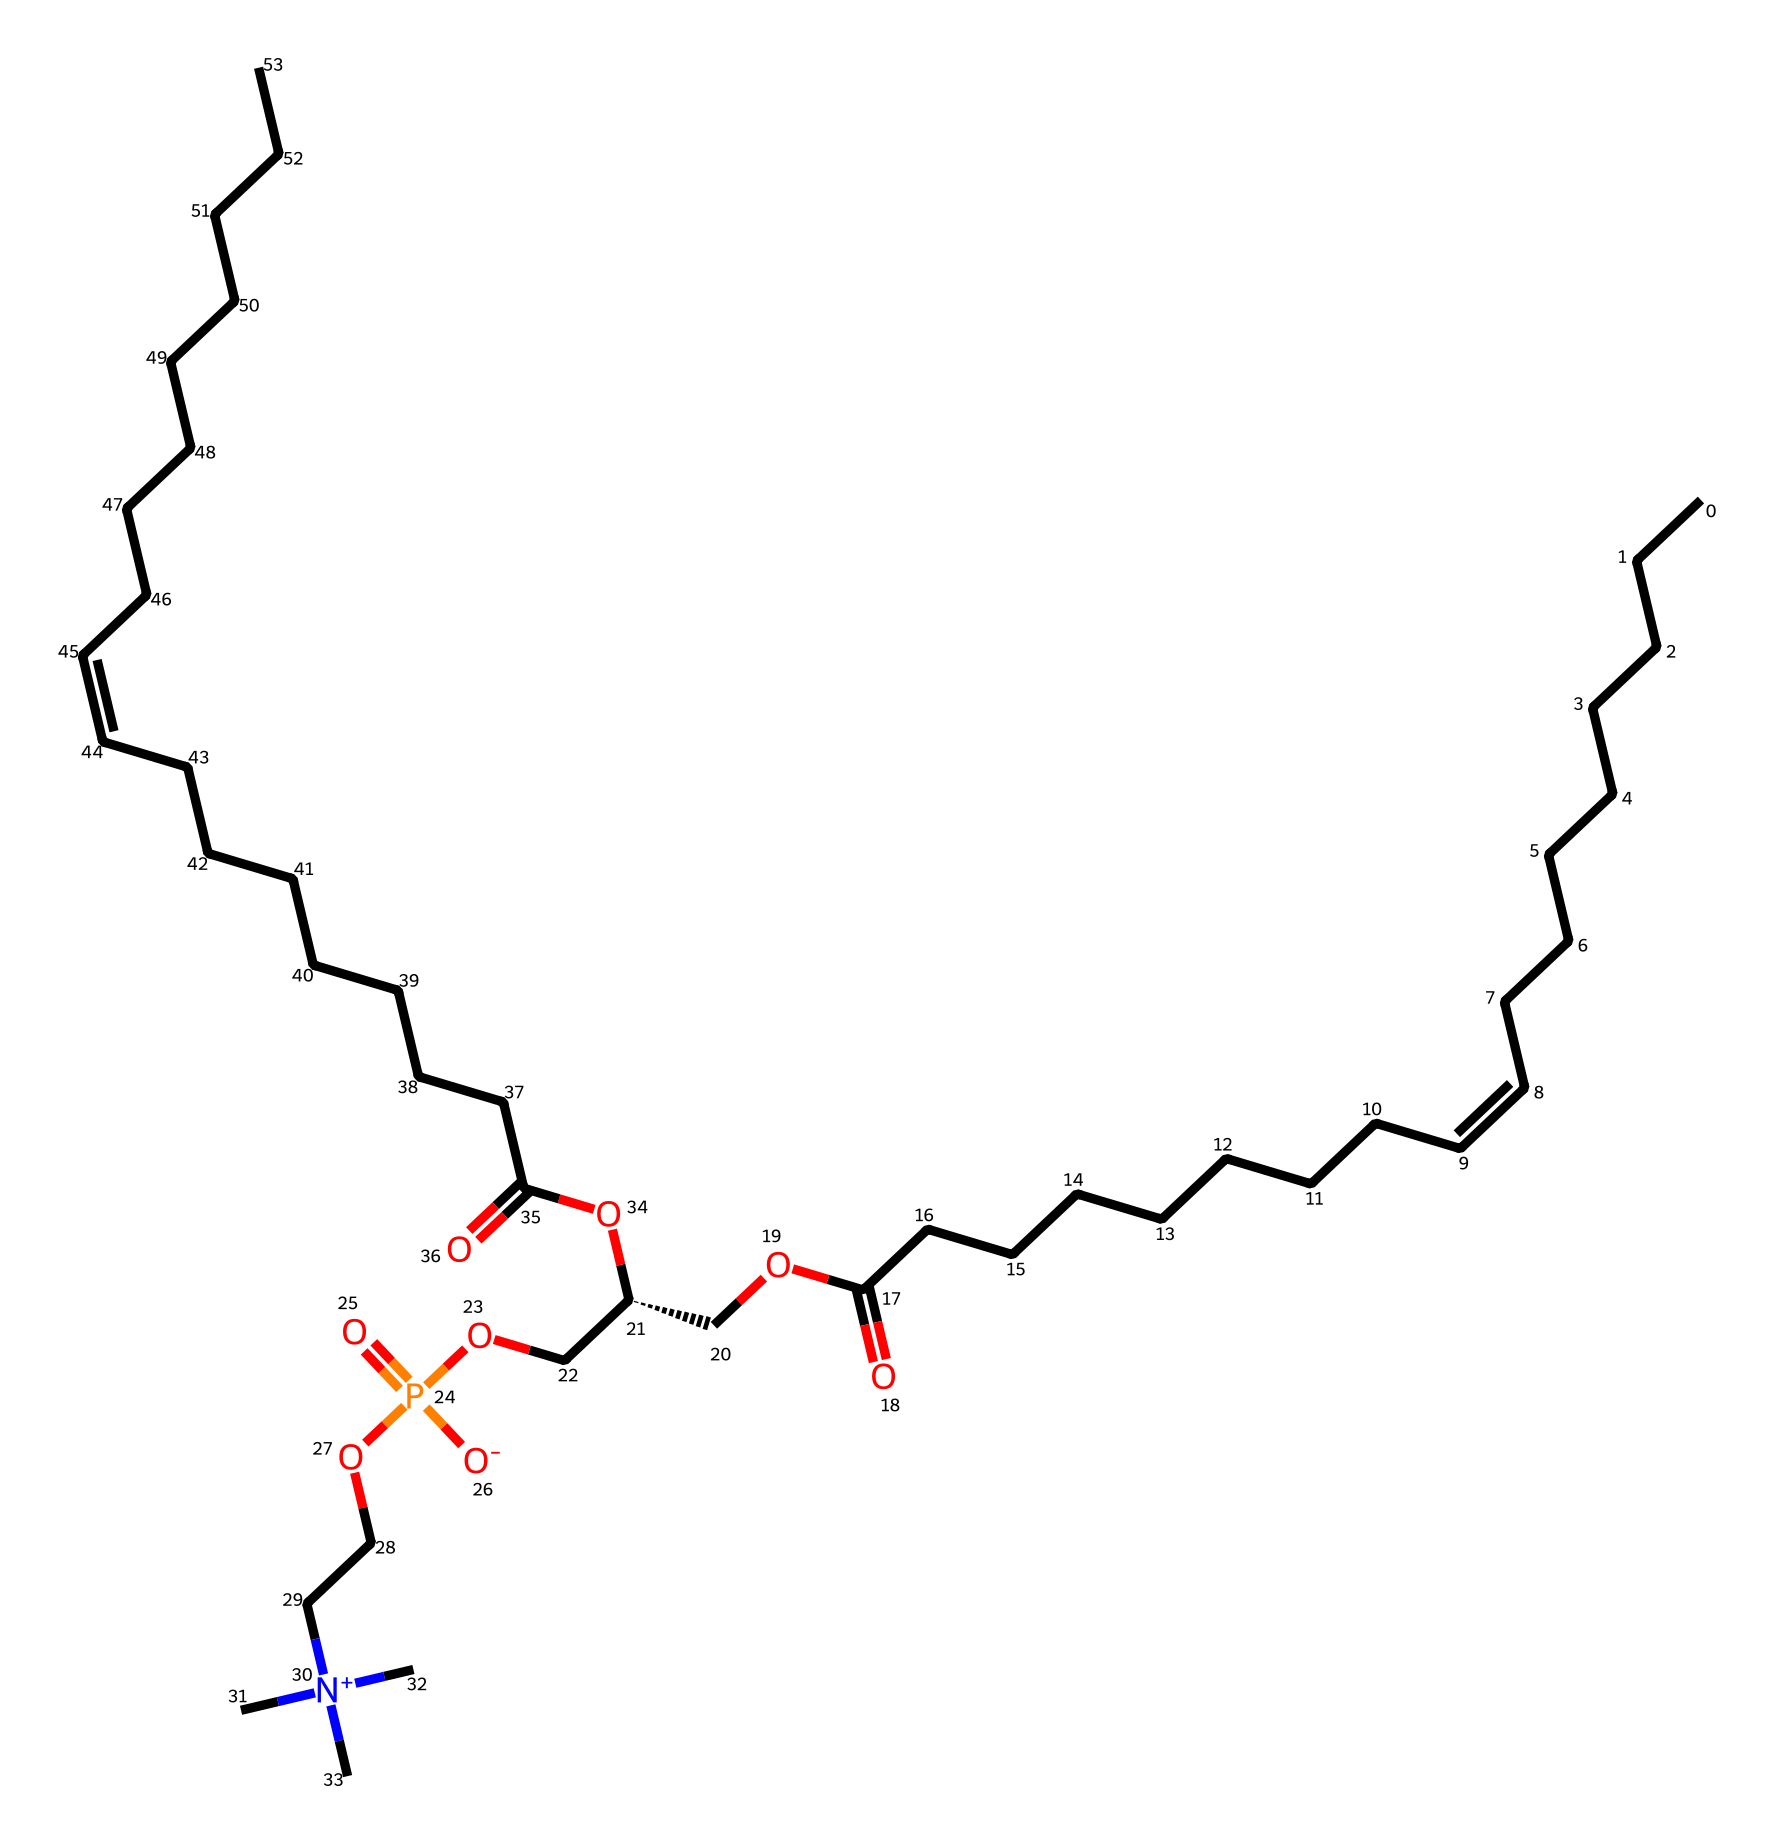What is the main functional group present in lecithin? In the chemical structure of lecithin, the phosphoric acid group is present, indicated by the presence of phosphate (P) bonded to oxygen (O) atoms. This is characteristic of phospholipids.
Answer: phosphate How many double bonds are there in the fatty acid chains? By examining the structure, there are two double bonds indicated by the "/C=C\" notation within the long carbon chains, suggesting the presence of unsaturation.
Answer: two What type of chemical is lecithin classified as? Lecithin is classified as a phospholipid because it contains both fatty acid chains and a phosphate functional group, aligning with the definition of phospholipids.
Answer: phospholipid How many carbon atoms are in the longest carbon chain? The longest carbon chain in the structure can be observed to contain 18 carbon atoms, as referred to in the notation that shows a continuous sequence of carbon atoms in the fatty acid portions.
Answer: eighteen What is the role of lecithin in processed foods? Lecithin functions primarily as an emulsifier, which helps to mix both water and oil components in food products, providing stability and texture.
Answer: emulsifier What is the significance of the chiral center in the structure of lecithin? The presence of the chiral center, represented by the [C@H] component, suggests that the molecule can exist in multiple stereoisomeric forms, which can affect its biological activity and functionality in food applications.
Answer: chirality 